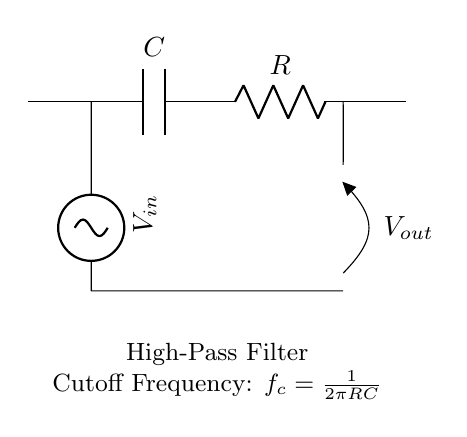What is the main function of this circuit? The main function of this circuit is to allow high-frequency signals to pass while attenuating or blocking low-frequency signals. This is characteristic of a high-pass filter.
Answer: high-pass filter What is the role of the capacitor in the circuit? The capacitor acts as a component that blocks low-frequency signals while allowing high-frequency signals to pass through to the output. Its impedance decreases with increasing frequency.
Answer: block low frequencies What does the 'R' in the circuit represent? The 'R' in the circuit represents the resistor, which is a component that provides resistance and works with the capacitor to set the cutoff frequency of the filter.
Answer: resistor What is the formula for calculating the cutoff frequency? The formula for calculating the cutoff frequency is defined as f_c = 1/(2πRC), which means the cutoff frequency is inversely related to both resistance and capacitance.
Answer: f_c = 1/(2πRC) If the resistance R is increased, what happens to the cutoff frequency? If the resistance R is increased, the cutoff frequency decreases, because they are inversely related in the formula for cutoff frequency.
Answer: decreases What type of input signal is suitable for this circuit? The circuit is suitable for sinusoidal input signals, as indicated by the sinusoidal voltage source, which represents typical alternating signals used in many applications.
Answer: sinusoidal What could be the impact of low-frequency interference on wireless crop monitoring devices? Low-frequency interference can disrupt the accuracy and reliability of wireless crop monitoring devices by overwhelming the desired signal, potentially leading to incorrect data being transmitted.
Answer: disrupt accuracy 